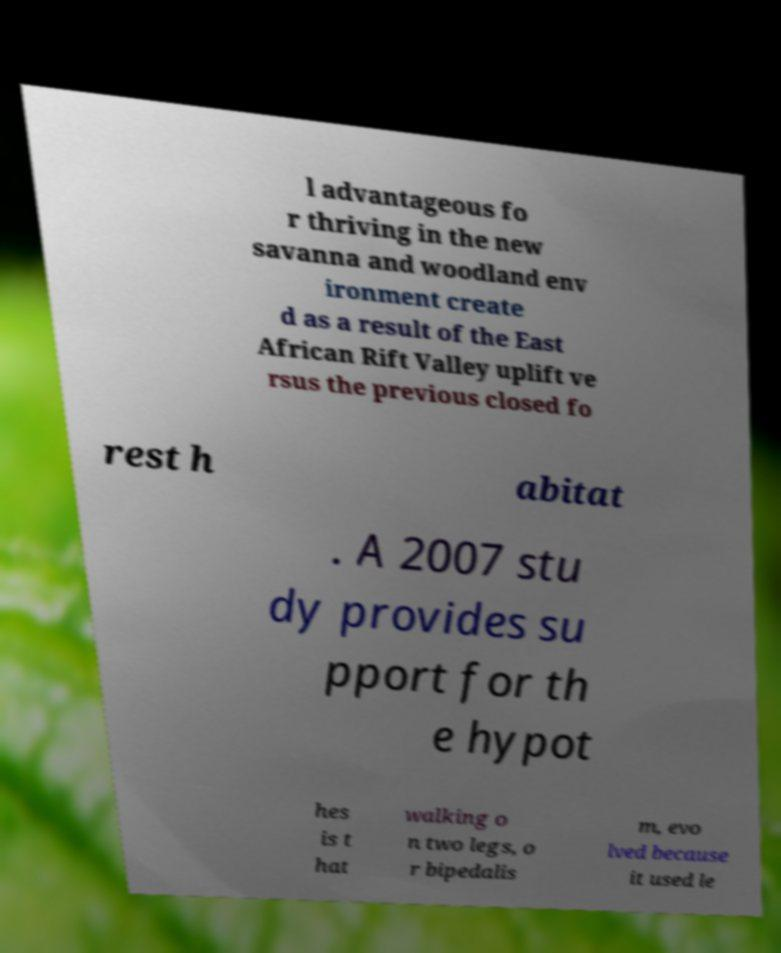I need the written content from this picture converted into text. Can you do that? l advantageous fo r thriving in the new savanna and woodland env ironment create d as a result of the East African Rift Valley uplift ve rsus the previous closed fo rest h abitat . A 2007 stu dy provides su pport for th e hypot hes is t hat walking o n two legs, o r bipedalis m, evo lved because it used le 